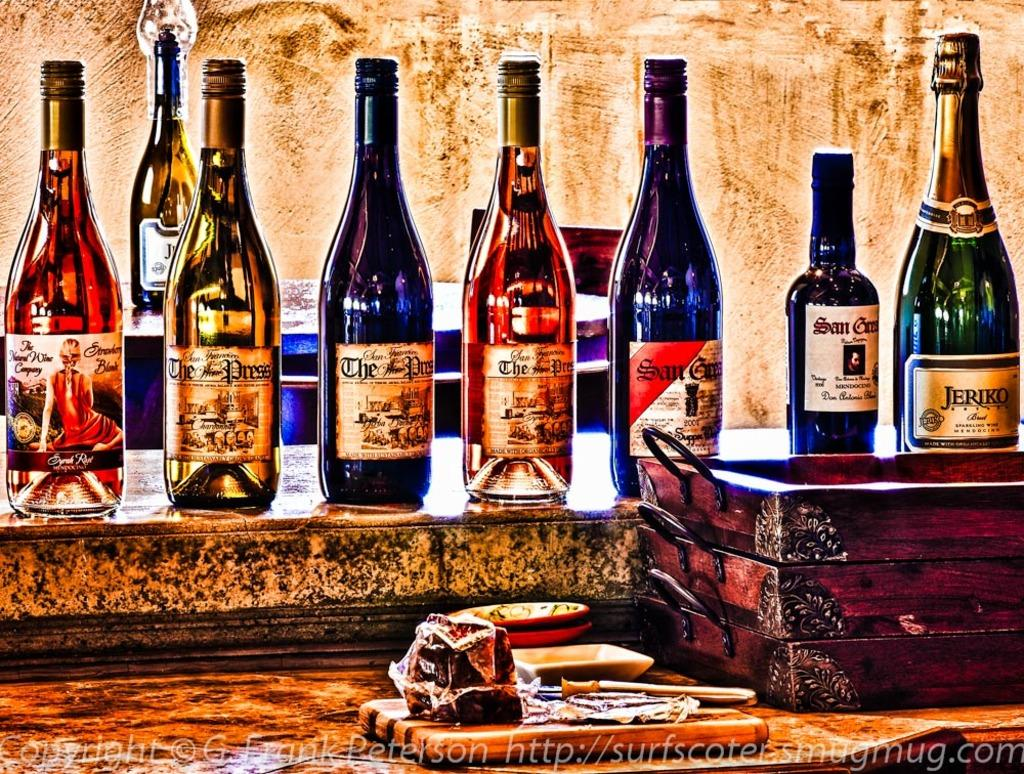What is located on the platform in the image? There are bottles on the platform in the image. What is placed in front of the bottles? There are wooden trays in front of the bottles. Can you describe any other objects visible in the image? Yes, there are other objects visible in the image, but their specific details are not mentioned in the provided facts. What can be found at the bottom of the image? There is text at the bottom of the image. What type of butter is being served on the sofa in the image? There is no sofa or butter present in the image. What type of club is visible in the image? There is no club present in the image. 